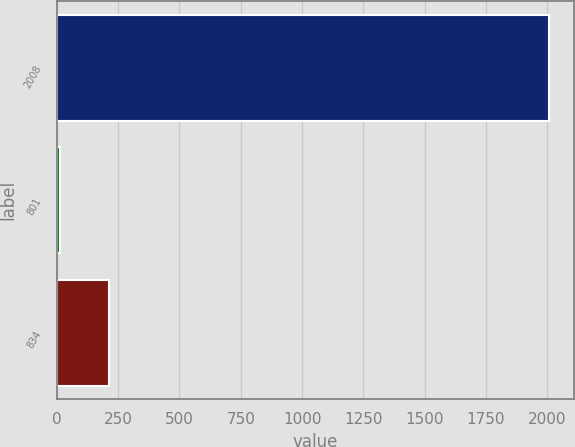Convert chart. <chart><loc_0><loc_0><loc_500><loc_500><bar_chart><fcel>2008<fcel>801<fcel>834<nl><fcel>2008<fcel>14<fcel>213.4<nl></chart> 